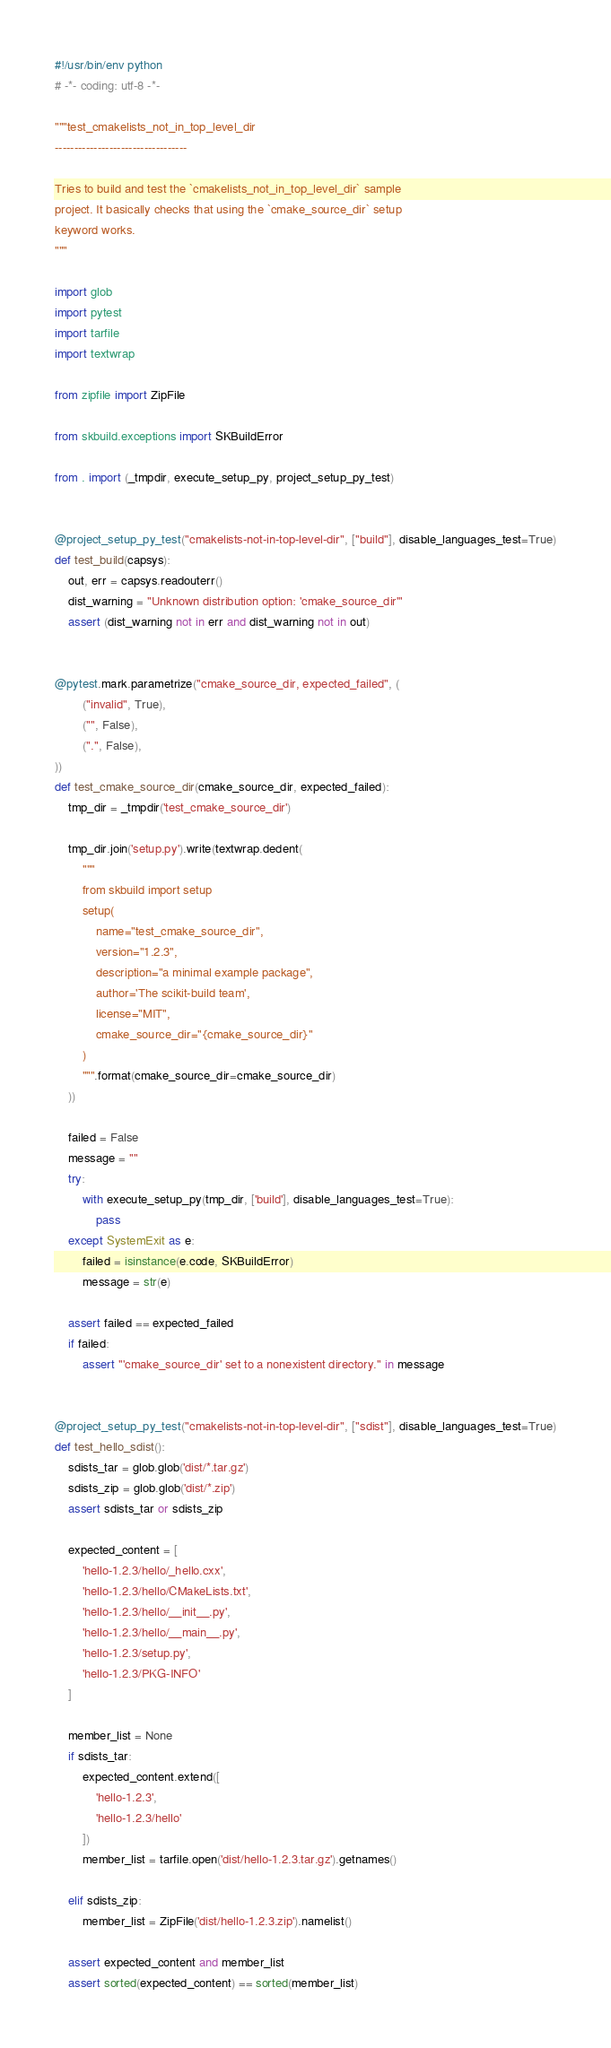Convert code to text. <code><loc_0><loc_0><loc_500><loc_500><_Python_>#!/usr/bin/env python
# -*- coding: utf-8 -*-

"""test_cmakelists_not_in_top_level_dir
----------------------------------

Tries to build and test the `cmakelists_not_in_top_level_dir` sample
project. It basically checks that using the `cmake_source_dir` setup
keyword works.
"""

import glob
import pytest
import tarfile
import textwrap

from zipfile import ZipFile

from skbuild.exceptions import SKBuildError

from . import (_tmpdir, execute_setup_py, project_setup_py_test)


@project_setup_py_test("cmakelists-not-in-top-level-dir", ["build"], disable_languages_test=True)
def test_build(capsys):
    out, err = capsys.readouterr()
    dist_warning = "Unknown distribution option: 'cmake_source_dir'"
    assert (dist_warning not in err and dist_warning not in out)


@pytest.mark.parametrize("cmake_source_dir, expected_failed", (
        ("invalid", True),
        ("", False),
        (".", False),
))
def test_cmake_source_dir(cmake_source_dir, expected_failed):
    tmp_dir = _tmpdir('test_cmake_source_dir')

    tmp_dir.join('setup.py').write(textwrap.dedent(
        """
        from skbuild import setup
        setup(
            name="test_cmake_source_dir",
            version="1.2.3",
            description="a minimal example package",
            author='The scikit-build team',
            license="MIT",
            cmake_source_dir="{cmake_source_dir}"
        )
        """.format(cmake_source_dir=cmake_source_dir)
    ))

    failed = False
    message = ""
    try:
        with execute_setup_py(tmp_dir, ['build'], disable_languages_test=True):
            pass
    except SystemExit as e:
        failed = isinstance(e.code, SKBuildError)
        message = str(e)

    assert failed == expected_failed
    if failed:
        assert "'cmake_source_dir' set to a nonexistent directory." in message


@project_setup_py_test("cmakelists-not-in-top-level-dir", ["sdist"], disable_languages_test=True)
def test_hello_sdist():
    sdists_tar = glob.glob('dist/*.tar.gz')
    sdists_zip = glob.glob('dist/*.zip')
    assert sdists_tar or sdists_zip

    expected_content = [
        'hello-1.2.3/hello/_hello.cxx',
        'hello-1.2.3/hello/CMakeLists.txt',
        'hello-1.2.3/hello/__init__.py',
        'hello-1.2.3/hello/__main__.py',
        'hello-1.2.3/setup.py',
        'hello-1.2.3/PKG-INFO'
    ]

    member_list = None
    if sdists_tar:
        expected_content.extend([
            'hello-1.2.3',
            'hello-1.2.3/hello'
        ])
        member_list = tarfile.open('dist/hello-1.2.3.tar.gz').getnames()

    elif sdists_zip:
        member_list = ZipFile('dist/hello-1.2.3.zip').namelist()

    assert expected_content and member_list
    assert sorted(expected_content) == sorted(member_list)
</code> 